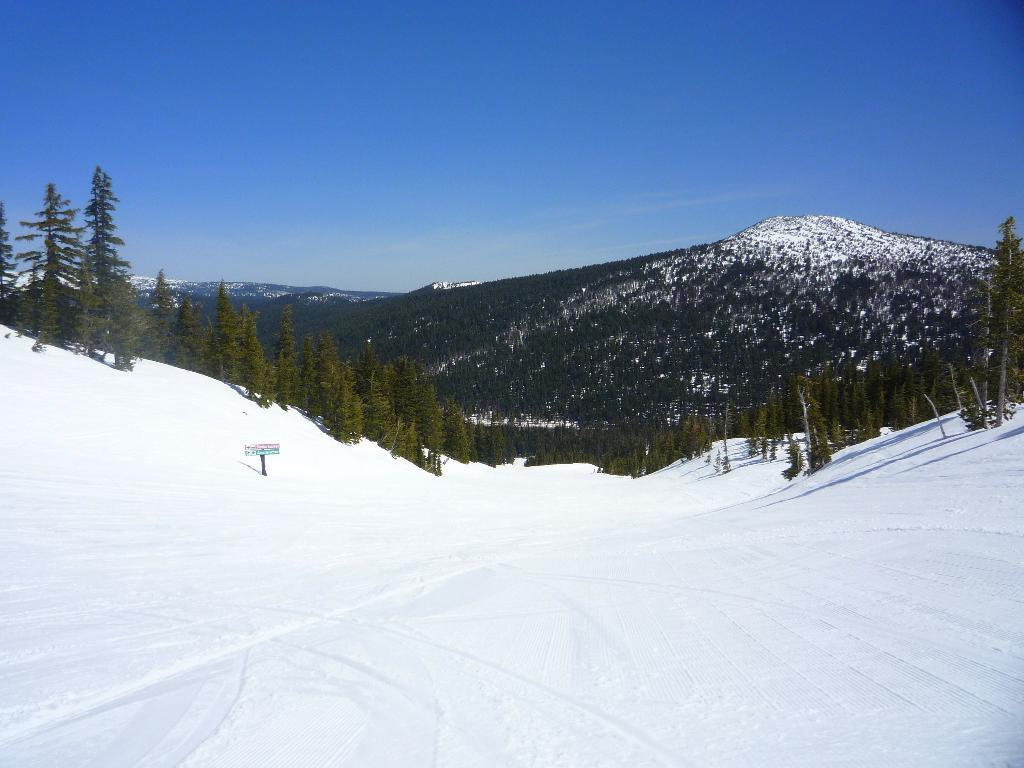What is the main object in the snow in the image? There is an object in the snow, but the specific object is not mentioned in the facts. What type of natural environment is depicted in the image? The image features trees, mountains covered with snow, and the sky, indicating a snowy landscape. What other objects can be seen in the image besides the object in the snow? There are other objects in the image, but their specific nature is not mentioned in the facts. How does the bed look like in the image? There is no bed present in the image; it features an object in the snow, trees, mountains covered with snow, and the sky. 